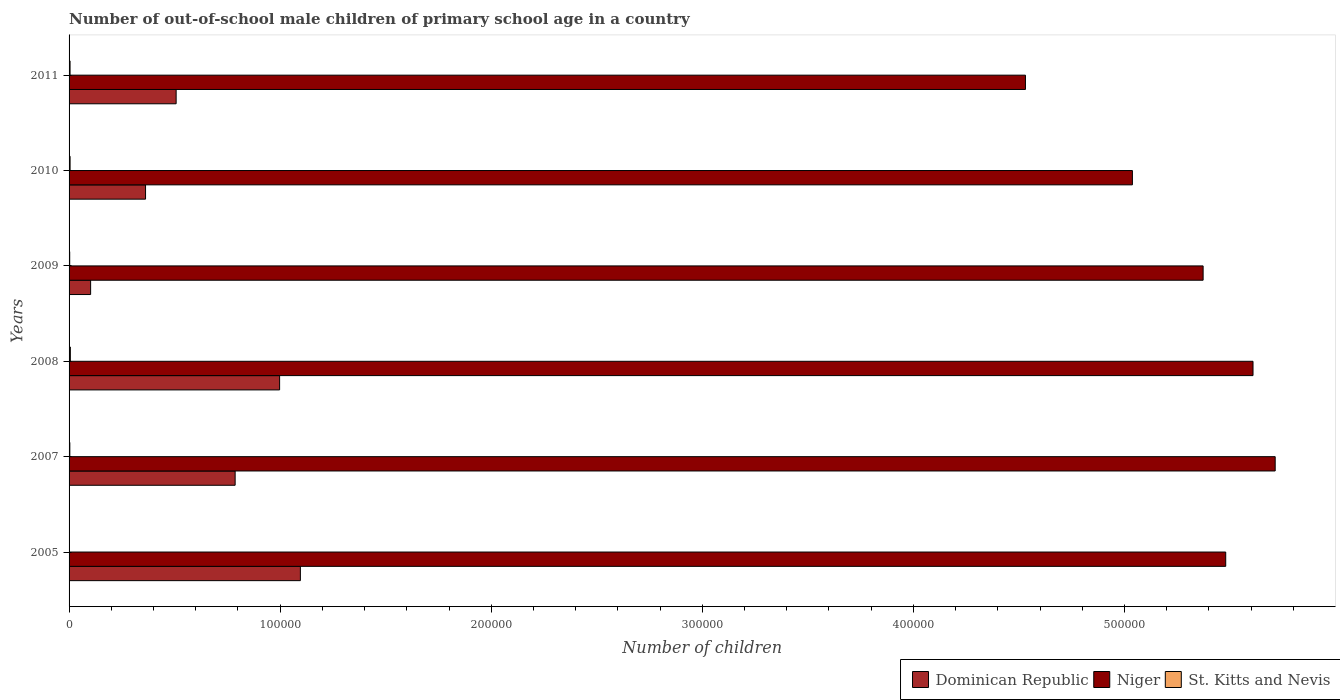How many different coloured bars are there?
Offer a terse response. 3. How many groups of bars are there?
Ensure brevity in your answer.  6. Are the number of bars on each tick of the Y-axis equal?
Provide a succinct answer. Yes. How many bars are there on the 5th tick from the top?
Provide a short and direct response. 3. How many bars are there on the 5th tick from the bottom?
Keep it short and to the point. 3. In how many cases, is the number of bars for a given year not equal to the number of legend labels?
Provide a succinct answer. 0. What is the number of out-of-school male children in Dominican Republic in 2005?
Your answer should be very brief. 1.10e+05. Across all years, what is the maximum number of out-of-school male children in St. Kitts and Nevis?
Offer a terse response. 611. Across all years, what is the minimum number of out-of-school male children in Niger?
Your answer should be very brief. 4.53e+05. In which year was the number of out-of-school male children in Dominican Republic minimum?
Your answer should be very brief. 2009. What is the total number of out-of-school male children in St. Kitts and Nevis in the graph?
Your response must be concise. 2398. What is the difference between the number of out-of-school male children in Dominican Republic in 2009 and that in 2011?
Offer a terse response. -4.05e+04. What is the difference between the number of out-of-school male children in Niger in 2009 and the number of out-of-school male children in St. Kitts and Nevis in 2008?
Provide a short and direct response. 5.37e+05. What is the average number of out-of-school male children in St. Kitts and Nevis per year?
Keep it short and to the point. 399.67. In the year 2009, what is the difference between the number of out-of-school male children in Niger and number of out-of-school male children in St. Kitts and Nevis?
Your response must be concise. 5.37e+05. In how many years, is the number of out-of-school male children in Niger greater than 360000 ?
Give a very brief answer. 6. What is the ratio of the number of out-of-school male children in St. Kitts and Nevis in 2008 to that in 2009?
Ensure brevity in your answer.  2.02. Is the difference between the number of out-of-school male children in Niger in 2005 and 2007 greater than the difference between the number of out-of-school male children in St. Kitts and Nevis in 2005 and 2007?
Ensure brevity in your answer.  No. What is the difference between the highest and the second highest number of out-of-school male children in Dominican Republic?
Provide a short and direct response. 9837. What is the difference between the highest and the lowest number of out-of-school male children in St. Kitts and Nevis?
Your response must be concise. 440. What does the 3rd bar from the top in 2005 represents?
Give a very brief answer. Dominican Republic. What does the 3rd bar from the bottom in 2008 represents?
Your answer should be very brief. St. Kitts and Nevis. How many bars are there?
Ensure brevity in your answer.  18. Does the graph contain any zero values?
Provide a succinct answer. No. How many legend labels are there?
Offer a very short reply. 3. What is the title of the graph?
Your answer should be very brief. Number of out-of-school male children of primary school age in a country. Does "Nicaragua" appear as one of the legend labels in the graph?
Your response must be concise. No. What is the label or title of the X-axis?
Provide a short and direct response. Number of children. What is the label or title of the Y-axis?
Keep it short and to the point. Years. What is the Number of children of Dominican Republic in 2005?
Your answer should be very brief. 1.10e+05. What is the Number of children of Niger in 2005?
Give a very brief answer. 5.48e+05. What is the Number of children in St. Kitts and Nevis in 2005?
Offer a very short reply. 171. What is the Number of children in Dominican Republic in 2007?
Your answer should be compact. 7.87e+04. What is the Number of children of Niger in 2007?
Your answer should be very brief. 5.71e+05. What is the Number of children of St. Kitts and Nevis in 2007?
Ensure brevity in your answer.  362. What is the Number of children of Dominican Republic in 2008?
Offer a very short reply. 9.97e+04. What is the Number of children of Niger in 2008?
Ensure brevity in your answer.  5.61e+05. What is the Number of children in St. Kitts and Nevis in 2008?
Provide a short and direct response. 611. What is the Number of children in Dominican Republic in 2009?
Your answer should be very brief. 1.02e+04. What is the Number of children in Niger in 2009?
Make the answer very short. 5.37e+05. What is the Number of children of St. Kitts and Nevis in 2009?
Your answer should be compact. 302. What is the Number of children of Dominican Republic in 2010?
Make the answer very short. 3.62e+04. What is the Number of children in Niger in 2010?
Ensure brevity in your answer.  5.04e+05. What is the Number of children in St. Kitts and Nevis in 2010?
Provide a succinct answer. 481. What is the Number of children of Dominican Republic in 2011?
Offer a terse response. 5.07e+04. What is the Number of children in Niger in 2011?
Give a very brief answer. 4.53e+05. What is the Number of children of St. Kitts and Nevis in 2011?
Provide a succinct answer. 471. Across all years, what is the maximum Number of children in Dominican Republic?
Your answer should be compact. 1.10e+05. Across all years, what is the maximum Number of children in Niger?
Your answer should be very brief. 5.71e+05. Across all years, what is the maximum Number of children in St. Kitts and Nevis?
Your answer should be compact. 611. Across all years, what is the minimum Number of children of Dominican Republic?
Your answer should be very brief. 1.02e+04. Across all years, what is the minimum Number of children in Niger?
Ensure brevity in your answer.  4.53e+05. Across all years, what is the minimum Number of children in St. Kitts and Nevis?
Your answer should be compact. 171. What is the total Number of children in Dominican Republic in the graph?
Keep it short and to the point. 3.85e+05. What is the total Number of children of Niger in the graph?
Make the answer very short. 3.17e+06. What is the total Number of children in St. Kitts and Nevis in the graph?
Your answer should be compact. 2398. What is the difference between the Number of children in Dominican Republic in 2005 and that in 2007?
Keep it short and to the point. 3.09e+04. What is the difference between the Number of children in Niger in 2005 and that in 2007?
Ensure brevity in your answer.  -2.34e+04. What is the difference between the Number of children of St. Kitts and Nevis in 2005 and that in 2007?
Offer a very short reply. -191. What is the difference between the Number of children of Dominican Republic in 2005 and that in 2008?
Your answer should be very brief. 9837. What is the difference between the Number of children of Niger in 2005 and that in 2008?
Give a very brief answer. -1.29e+04. What is the difference between the Number of children of St. Kitts and Nevis in 2005 and that in 2008?
Make the answer very short. -440. What is the difference between the Number of children in Dominican Republic in 2005 and that in 2009?
Your answer should be very brief. 9.94e+04. What is the difference between the Number of children of Niger in 2005 and that in 2009?
Offer a terse response. 1.07e+04. What is the difference between the Number of children of St. Kitts and Nevis in 2005 and that in 2009?
Your answer should be very brief. -131. What is the difference between the Number of children in Dominican Republic in 2005 and that in 2010?
Ensure brevity in your answer.  7.34e+04. What is the difference between the Number of children in Niger in 2005 and that in 2010?
Your answer should be compact. 4.42e+04. What is the difference between the Number of children of St. Kitts and Nevis in 2005 and that in 2010?
Ensure brevity in your answer.  -310. What is the difference between the Number of children in Dominican Republic in 2005 and that in 2011?
Offer a very short reply. 5.89e+04. What is the difference between the Number of children in Niger in 2005 and that in 2011?
Keep it short and to the point. 9.49e+04. What is the difference between the Number of children of St. Kitts and Nevis in 2005 and that in 2011?
Make the answer very short. -300. What is the difference between the Number of children in Dominican Republic in 2007 and that in 2008?
Keep it short and to the point. -2.11e+04. What is the difference between the Number of children of Niger in 2007 and that in 2008?
Give a very brief answer. 1.05e+04. What is the difference between the Number of children in St. Kitts and Nevis in 2007 and that in 2008?
Your answer should be very brief. -249. What is the difference between the Number of children in Dominican Republic in 2007 and that in 2009?
Provide a succinct answer. 6.85e+04. What is the difference between the Number of children of Niger in 2007 and that in 2009?
Your answer should be very brief. 3.41e+04. What is the difference between the Number of children in Dominican Republic in 2007 and that in 2010?
Give a very brief answer. 4.24e+04. What is the difference between the Number of children of Niger in 2007 and that in 2010?
Keep it short and to the point. 6.76e+04. What is the difference between the Number of children in St. Kitts and Nevis in 2007 and that in 2010?
Your response must be concise. -119. What is the difference between the Number of children of Dominican Republic in 2007 and that in 2011?
Offer a very short reply. 2.80e+04. What is the difference between the Number of children of Niger in 2007 and that in 2011?
Make the answer very short. 1.18e+05. What is the difference between the Number of children of St. Kitts and Nevis in 2007 and that in 2011?
Ensure brevity in your answer.  -109. What is the difference between the Number of children in Dominican Republic in 2008 and that in 2009?
Your response must be concise. 8.95e+04. What is the difference between the Number of children in Niger in 2008 and that in 2009?
Your answer should be compact. 2.36e+04. What is the difference between the Number of children of St. Kitts and Nevis in 2008 and that in 2009?
Your answer should be very brief. 309. What is the difference between the Number of children in Dominican Republic in 2008 and that in 2010?
Offer a terse response. 6.35e+04. What is the difference between the Number of children of Niger in 2008 and that in 2010?
Your answer should be compact. 5.71e+04. What is the difference between the Number of children in St. Kitts and Nevis in 2008 and that in 2010?
Provide a succinct answer. 130. What is the difference between the Number of children of Dominican Republic in 2008 and that in 2011?
Provide a succinct answer. 4.90e+04. What is the difference between the Number of children of Niger in 2008 and that in 2011?
Provide a succinct answer. 1.08e+05. What is the difference between the Number of children of St. Kitts and Nevis in 2008 and that in 2011?
Keep it short and to the point. 140. What is the difference between the Number of children in Dominican Republic in 2009 and that in 2010?
Keep it short and to the point. -2.60e+04. What is the difference between the Number of children in Niger in 2009 and that in 2010?
Provide a short and direct response. 3.35e+04. What is the difference between the Number of children of St. Kitts and Nevis in 2009 and that in 2010?
Make the answer very short. -179. What is the difference between the Number of children of Dominican Republic in 2009 and that in 2011?
Offer a very short reply. -4.05e+04. What is the difference between the Number of children of Niger in 2009 and that in 2011?
Keep it short and to the point. 8.42e+04. What is the difference between the Number of children in St. Kitts and Nevis in 2009 and that in 2011?
Make the answer very short. -169. What is the difference between the Number of children in Dominican Republic in 2010 and that in 2011?
Provide a succinct answer. -1.45e+04. What is the difference between the Number of children in Niger in 2010 and that in 2011?
Keep it short and to the point. 5.07e+04. What is the difference between the Number of children of St. Kitts and Nevis in 2010 and that in 2011?
Your answer should be very brief. 10. What is the difference between the Number of children of Dominican Republic in 2005 and the Number of children of Niger in 2007?
Provide a short and direct response. -4.62e+05. What is the difference between the Number of children in Dominican Republic in 2005 and the Number of children in St. Kitts and Nevis in 2007?
Your answer should be very brief. 1.09e+05. What is the difference between the Number of children in Niger in 2005 and the Number of children in St. Kitts and Nevis in 2007?
Your response must be concise. 5.48e+05. What is the difference between the Number of children in Dominican Republic in 2005 and the Number of children in Niger in 2008?
Offer a very short reply. -4.51e+05. What is the difference between the Number of children of Dominican Republic in 2005 and the Number of children of St. Kitts and Nevis in 2008?
Your response must be concise. 1.09e+05. What is the difference between the Number of children in Niger in 2005 and the Number of children in St. Kitts and Nevis in 2008?
Your answer should be compact. 5.47e+05. What is the difference between the Number of children of Dominican Republic in 2005 and the Number of children of Niger in 2009?
Provide a succinct answer. -4.28e+05. What is the difference between the Number of children in Dominican Republic in 2005 and the Number of children in St. Kitts and Nevis in 2009?
Give a very brief answer. 1.09e+05. What is the difference between the Number of children of Niger in 2005 and the Number of children of St. Kitts and Nevis in 2009?
Offer a terse response. 5.48e+05. What is the difference between the Number of children of Dominican Republic in 2005 and the Number of children of Niger in 2010?
Your response must be concise. -3.94e+05. What is the difference between the Number of children in Dominican Republic in 2005 and the Number of children in St. Kitts and Nevis in 2010?
Your response must be concise. 1.09e+05. What is the difference between the Number of children in Niger in 2005 and the Number of children in St. Kitts and Nevis in 2010?
Keep it short and to the point. 5.47e+05. What is the difference between the Number of children in Dominican Republic in 2005 and the Number of children in Niger in 2011?
Ensure brevity in your answer.  -3.44e+05. What is the difference between the Number of children in Dominican Republic in 2005 and the Number of children in St. Kitts and Nevis in 2011?
Offer a terse response. 1.09e+05. What is the difference between the Number of children in Niger in 2005 and the Number of children in St. Kitts and Nevis in 2011?
Offer a terse response. 5.48e+05. What is the difference between the Number of children of Dominican Republic in 2007 and the Number of children of Niger in 2008?
Ensure brevity in your answer.  -4.82e+05. What is the difference between the Number of children of Dominican Republic in 2007 and the Number of children of St. Kitts and Nevis in 2008?
Make the answer very short. 7.81e+04. What is the difference between the Number of children of Niger in 2007 and the Number of children of St. Kitts and Nevis in 2008?
Give a very brief answer. 5.71e+05. What is the difference between the Number of children of Dominican Republic in 2007 and the Number of children of Niger in 2009?
Your answer should be compact. -4.59e+05. What is the difference between the Number of children of Dominican Republic in 2007 and the Number of children of St. Kitts and Nevis in 2009?
Keep it short and to the point. 7.84e+04. What is the difference between the Number of children in Niger in 2007 and the Number of children in St. Kitts and Nevis in 2009?
Keep it short and to the point. 5.71e+05. What is the difference between the Number of children of Dominican Republic in 2007 and the Number of children of Niger in 2010?
Ensure brevity in your answer.  -4.25e+05. What is the difference between the Number of children in Dominican Republic in 2007 and the Number of children in St. Kitts and Nevis in 2010?
Ensure brevity in your answer.  7.82e+04. What is the difference between the Number of children of Niger in 2007 and the Number of children of St. Kitts and Nevis in 2010?
Your answer should be very brief. 5.71e+05. What is the difference between the Number of children in Dominican Republic in 2007 and the Number of children in Niger in 2011?
Provide a short and direct response. -3.74e+05. What is the difference between the Number of children in Dominican Republic in 2007 and the Number of children in St. Kitts and Nevis in 2011?
Keep it short and to the point. 7.82e+04. What is the difference between the Number of children in Niger in 2007 and the Number of children in St. Kitts and Nevis in 2011?
Provide a short and direct response. 5.71e+05. What is the difference between the Number of children of Dominican Republic in 2008 and the Number of children of Niger in 2009?
Ensure brevity in your answer.  -4.38e+05. What is the difference between the Number of children in Dominican Republic in 2008 and the Number of children in St. Kitts and Nevis in 2009?
Give a very brief answer. 9.94e+04. What is the difference between the Number of children of Niger in 2008 and the Number of children of St. Kitts and Nevis in 2009?
Offer a very short reply. 5.61e+05. What is the difference between the Number of children in Dominican Republic in 2008 and the Number of children in Niger in 2010?
Provide a short and direct response. -4.04e+05. What is the difference between the Number of children in Dominican Republic in 2008 and the Number of children in St. Kitts and Nevis in 2010?
Give a very brief answer. 9.93e+04. What is the difference between the Number of children in Niger in 2008 and the Number of children in St. Kitts and Nevis in 2010?
Offer a very short reply. 5.60e+05. What is the difference between the Number of children in Dominican Republic in 2008 and the Number of children in Niger in 2011?
Your answer should be compact. -3.53e+05. What is the difference between the Number of children of Dominican Republic in 2008 and the Number of children of St. Kitts and Nevis in 2011?
Your answer should be compact. 9.93e+04. What is the difference between the Number of children in Niger in 2008 and the Number of children in St. Kitts and Nevis in 2011?
Offer a very short reply. 5.60e+05. What is the difference between the Number of children of Dominican Republic in 2009 and the Number of children of Niger in 2010?
Your answer should be very brief. -4.94e+05. What is the difference between the Number of children of Dominican Republic in 2009 and the Number of children of St. Kitts and Nevis in 2010?
Provide a short and direct response. 9728. What is the difference between the Number of children in Niger in 2009 and the Number of children in St. Kitts and Nevis in 2010?
Give a very brief answer. 5.37e+05. What is the difference between the Number of children of Dominican Republic in 2009 and the Number of children of Niger in 2011?
Make the answer very short. -4.43e+05. What is the difference between the Number of children of Dominican Republic in 2009 and the Number of children of St. Kitts and Nevis in 2011?
Offer a very short reply. 9738. What is the difference between the Number of children in Niger in 2009 and the Number of children in St. Kitts and Nevis in 2011?
Offer a terse response. 5.37e+05. What is the difference between the Number of children of Dominican Republic in 2010 and the Number of children of Niger in 2011?
Offer a terse response. -4.17e+05. What is the difference between the Number of children in Dominican Republic in 2010 and the Number of children in St. Kitts and Nevis in 2011?
Offer a very short reply. 3.58e+04. What is the difference between the Number of children in Niger in 2010 and the Number of children in St. Kitts and Nevis in 2011?
Your answer should be compact. 5.03e+05. What is the average Number of children in Dominican Republic per year?
Your answer should be compact. 6.42e+04. What is the average Number of children of Niger per year?
Provide a short and direct response. 5.29e+05. What is the average Number of children of St. Kitts and Nevis per year?
Your response must be concise. 399.67. In the year 2005, what is the difference between the Number of children in Dominican Republic and Number of children in Niger?
Your answer should be very brief. -4.38e+05. In the year 2005, what is the difference between the Number of children of Dominican Republic and Number of children of St. Kitts and Nevis?
Make the answer very short. 1.09e+05. In the year 2005, what is the difference between the Number of children in Niger and Number of children in St. Kitts and Nevis?
Offer a terse response. 5.48e+05. In the year 2007, what is the difference between the Number of children in Dominican Republic and Number of children in Niger?
Ensure brevity in your answer.  -4.93e+05. In the year 2007, what is the difference between the Number of children of Dominican Republic and Number of children of St. Kitts and Nevis?
Provide a short and direct response. 7.83e+04. In the year 2007, what is the difference between the Number of children in Niger and Number of children in St. Kitts and Nevis?
Your response must be concise. 5.71e+05. In the year 2008, what is the difference between the Number of children of Dominican Republic and Number of children of Niger?
Ensure brevity in your answer.  -4.61e+05. In the year 2008, what is the difference between the Number of children in Dominican Republic and Number of children in St. Kitts and Nevis?
Give a very brief answer. 9.91e+04. In the year 2008, what is the difference between the Number of children of Niger and Number of children of St. Kitts and Nevis?
Offer a very short reply. 5.60e+05. In the year 2009, what is the difference between the Number of children of Dominican Republic and Number of children of Niger?
Your response must be concise. -5.27e+05. In the year 2009, what is the difference between the Number of children of Dominican Republic and Number of children of St. Kitts and Nevis?
Ensure brevity in your answer.  9907. In the year 2009, what is the difference between the Number of children in Niger and Number of children in St. Kitts and Nevis?
Give a very brief answer. 5.37e+05. In the year 2010, what is the difference between the Number of children of Dominican Republic and Number of children of Niger?
Offer a very short reply. -4.68e+05. In the year 2010, what is the difference between the Number of children in Dominican Republic and Number of children in St. Kitts and Nevis?
Offer a terse response. 3.58e+04. In the year 2010, what is the difference between the Number of children of Niger and Number of children of St. Kitts and Nevis?
Ensure brevity in your answer.  5.03e+05. In the year 2011, what is the difference between the Number of children of Dominican Republic and Number of children of Niger?
Give a very brief answer. -4.02e+05. In the year 2011, what is the difference between the Number of children of Dominican Republic and Number of children of St. Kitts and Nevis?
Your response must be concise. 5.03e+04. In the year 2011, what is the difference between the Number of children of Niger and Number of children of St. Kitts and Nevis?
Provide a short and direct response. 4.53e+05. What is the ratio of the Number of children of Dominican Republic in 2005 to that in 2007?
Your answer should be compact. 1.39. What is the ratio of the Number of children in Niger in 2005 to that in 2007?
Keep it short and to the point. 0.96. What is the ratio of the Number of children of St. Kitts and Nevis in 2005 to that in 2007?
Offer a terse response. 0.47. What is the ratio of the Number of children in Dominican Republic in 2005 to that in 2008?
Keep it short and to the point. 1.1. What is the ratio of the Number of children of St. Kitts and Nevis in 2005 to that in 2008?
Offer a very short reply. 0.28. What is the ratio of the Number of children in Dominican Republic in 2005 to that in 2009?
Your response must be concise. 10.73. What is the ratio of the Number of children of Niger in 2005 to that in 2009?
Offer a terse response. 1.02. What is the ratio of the Number of children of St. Kitts and Nevis in 2005 to that in 2009?
Your response must be concise. 0.57. What is the ratio of the Number of children in Dominican Republic in 2005 to that in 2010?
Make the answer very short. 3.02. What is the ratio of the Number of children of Niger in 2005 to that in 2010?
Give a very brief answer. 1.09. What is the ratio of the Number of children of St. Kitts and Nevis in 2005 to that in 2010?
Your answer should be very brief. 0.36. What is the ratio of the Number of children of Dominican Republic in 2005 to that in 2011?
Keep it short and to the point. 2.16. What is the ratio of the Number of children of Niger in 2005 to that in 2011?
Give a very brief answer. 1.21. What is the ratio of the Number of children of St. Kitts and Nevis in 2005 to that in 2011?
Give a very brief answer. 0.36. What is the ratio of the Number of children in Dominican Republic in 2007 to that in 2008?
Make the answer very short. 0.79. What is the ratio of the Number of children in Niger in 2007 to that in 2008?
Provide a succinct answer. 1.02. What is the ratio of the Number of children of St. Kitts and Nevis in 2007 to that in 2008?
Your answer should be very brief. 0.59. What is the ratio of the Number of children of Dominican Republic in 2007 to that in 2009?
Offer a very short reply. 7.71. What is the ratio of the Number of children of Niger in 2007 to that in 2009?
Make the answer very short. 1.06. What is the ratio of the Number of children of St. Kitts and Nevis in 2007 to that in 2009?
Offer a terse response. 1.2. What is the ratio of the Number of children of Dominican Republic in 2007 to that in 2010?
Your answer should be very brief. 2.17. What is the ratio of the Number of children of Niger in 2007 to that in 2010?
Give a very brief answer. 1.13. What is the ratio of the Number of children of St. Kitts and Nevis in 2007 to that in 2010?
Offer a terse response. 0.75. What is the ratio of the Number of children in Dominican Republic in 2007 to that in 2011?
Ensure brevity in your answer.  1.55. What is the ratio of the Number of children of Niger in 2007 to that in 2011?
Your answer should be compact. 1.26. What is the ratio of the Number of children of St. Kitts and Nevis in 2007 to that in 2011?
Your answer should be compact. 0.77. What is the ratio of the Number of children in Dominican Republic in 2008 to that in 2009?
Keep it short and to the point. 9.77. What is the ratio of the Number of children of Niger in 2008 to that in 2009?
Make the answer very short. 1.04. What is the ratio of the Number of children of St. Kitts and Nevis in 2008 to that in 2009?
Provide a succinct answer. 2.02. What is the ratio of the Number of children of Dominican Republic in 2008 to that in 2010?
Your answer should be very brief. 2.75. What is the ratio of the Number of children of Niger in 2008 to that in 2010?
Offer a terse response. 1.11. What is the ratio of the Number of children in St. Kitts and Nevis in 2008 to that in 2010?
Offer a very short reply. 1.27. What is the ratio of the Number of children in Dominican Republic in 2008 to that in 2011?
Offer a terse response. 1.97. What is the ratio of the Number of children of Niger in 2008 to that in 2011?
Your answer should be very brief. 1.24. What is the ratio of the Number of children of St. Kitts and Nevis in 2008 to that in 2011?
Give a very brief answer. 1.3. What is the ratio of the Number of children in Dominican Republic in 2009 to that in 2010?
Give a very brief answer. 0.28. What is the ratio of the Number of children of Niger in 2009 to that in 2010?
Keep it short and to the point. 1.07. What is the ratio of the Number of children of St. Kitts and Nevis in 2009 to that in 2010?
Provide a succinct answer. 0.63. What is the ratio of the Number of children of Dominican Republic in 2009 to that in 2011?
Make the answer very short. 0.2. What is the ratio of the Number of children in Niger in 2009 to that in 2011?
Your answer should be very brief. 1.19. What is the ratio of the Number of children of St. Kitts and Nevis in 2009 to that in 2011?
Your answer should be compact. 0.64. What is the ratio of the Number of children in Dominican Republic in 2010 to that in 2011?
Your answer should be compact. 0.71. What is the ratio of the Number of children in Niger in 2010 to that in 2011?
Keep it short and to the point. 1.11. What is the ratio of the Number of children in St. Kitts and Nevis in 2010 to that in 2011?
Provide a short and direct response. 1.02. What is the difference between the highest and the second highest Number of children of Dominican Republic?
Make the answer very short. 9837. What is the difference between the highest and the second highest Number of children in Niger?
Offer a terse response. 1.05e+04. What is the difference between the highest and the second highest Number of children in St. Kitts and Nevis?
Your response must be concise. 130. What is the difference between the highest and the lowest Number of children in Dominican Republic?
Your response must be concise. 9.94e+04. What is the difference between the highest and the lowest Number of children in Niger?
Offer a very short reply. 1.18e+05. What is the difference between the highest and the lowest Number of children in St. Kitts and Nevis?
Your response must be concise. 440. 